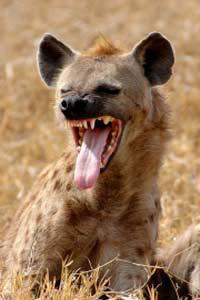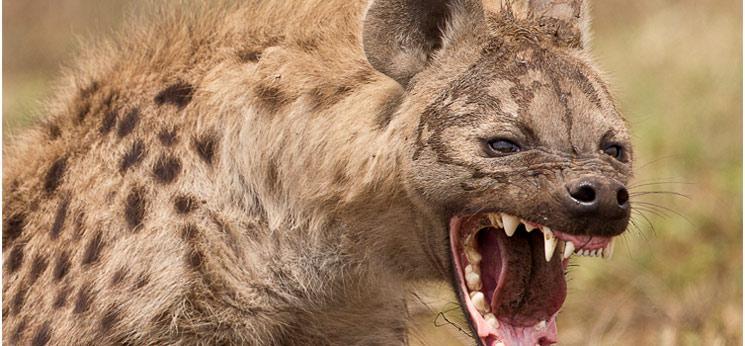The first image is the image on the left, the second image is the image on the right. Considering the images on both sides, is "The left image contains one hyena with its teeth exposed and their tongue hanging out." valid? Answer yes or no. Yes. The first image is the image on the left, the second image is the image on the right. For the images displayed, is the sentence "The right image shows at least one hyena grasping at a zebra carcass with its black and white striped hide still partly intact." factually correct? Answer yes or no. No. 